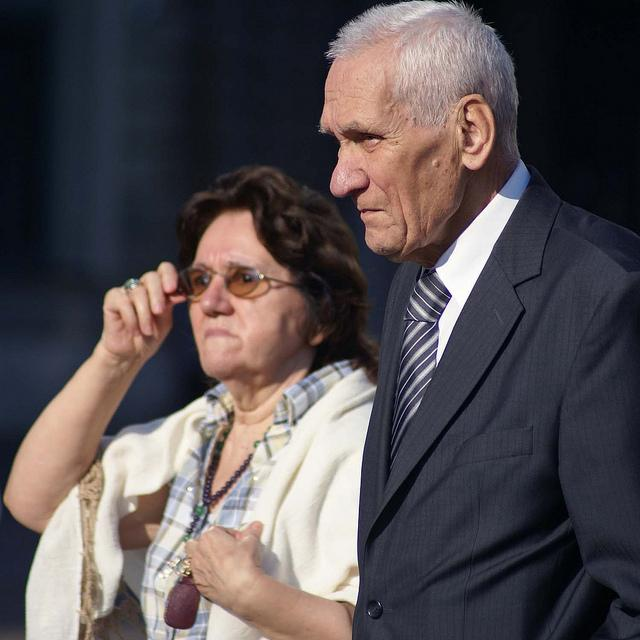Why are her glasses that color? tinted 